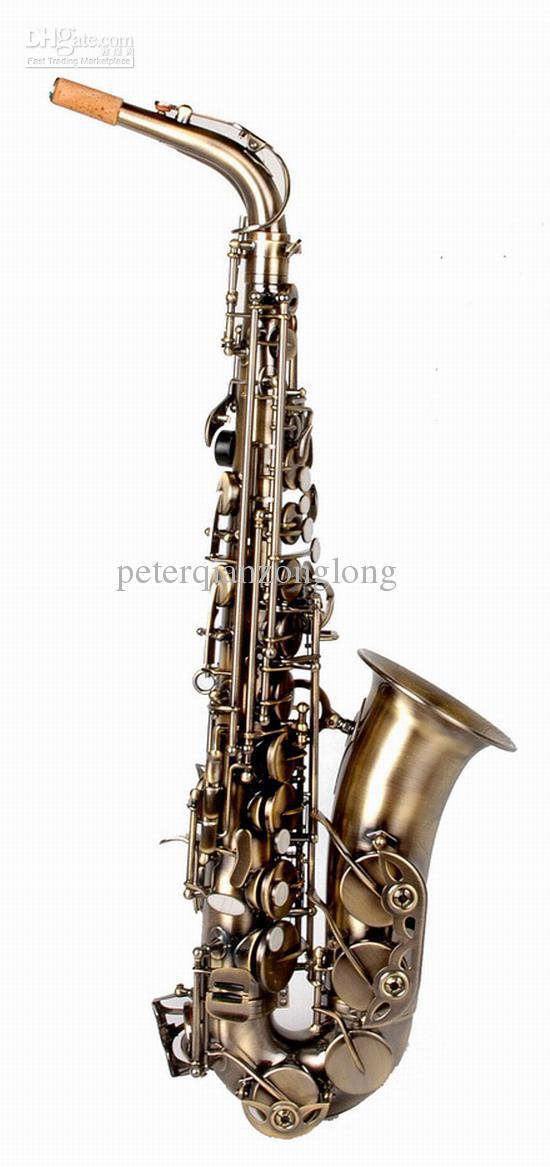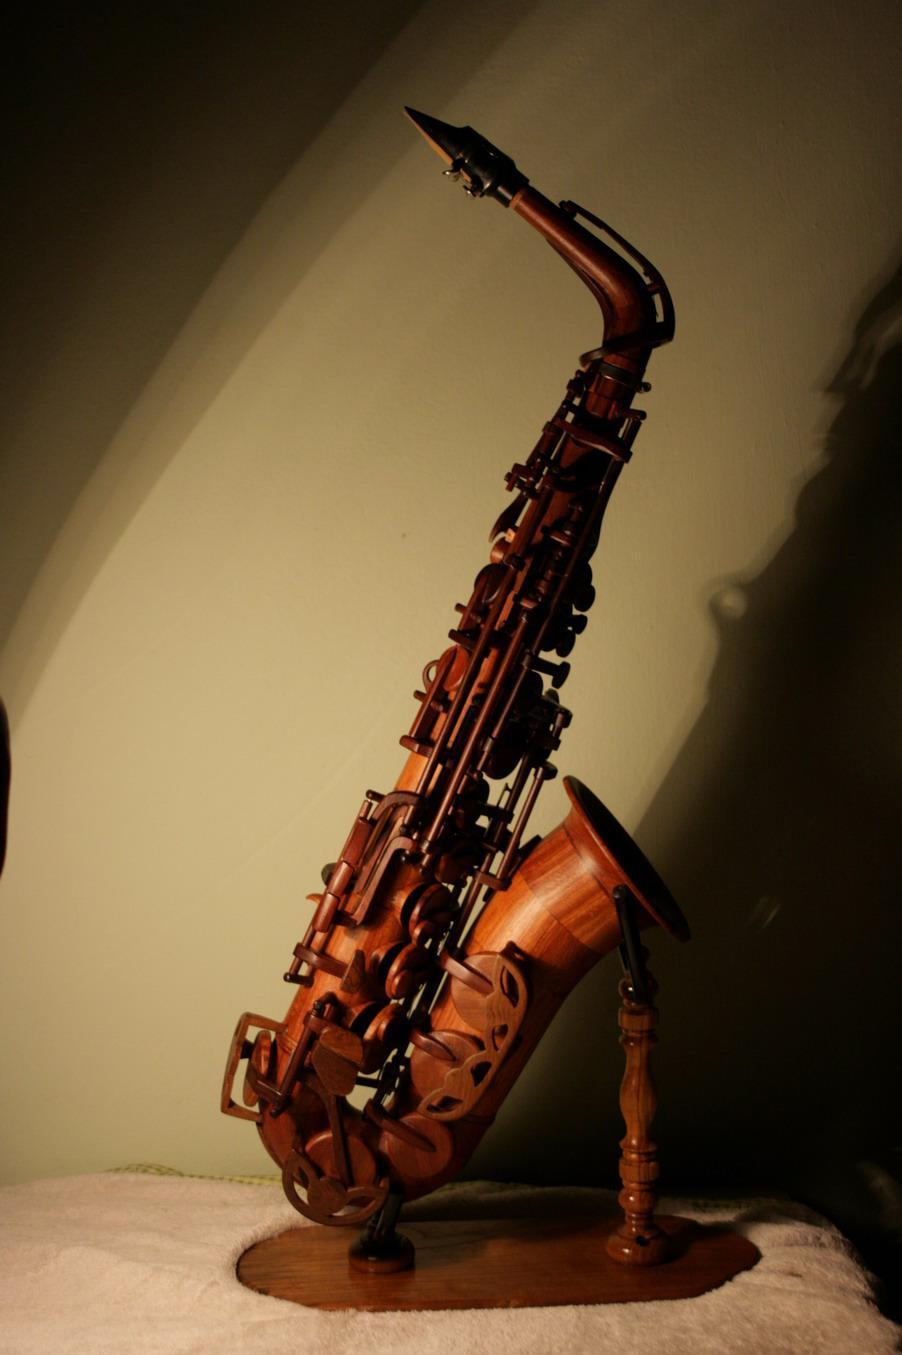The first image is the image on the left, the second image is the image on the right. Examine the images to the left and right. Is the description "The saxophone in the image on the left is against a solid white background." accurate? Answer yes or no. Yes. 